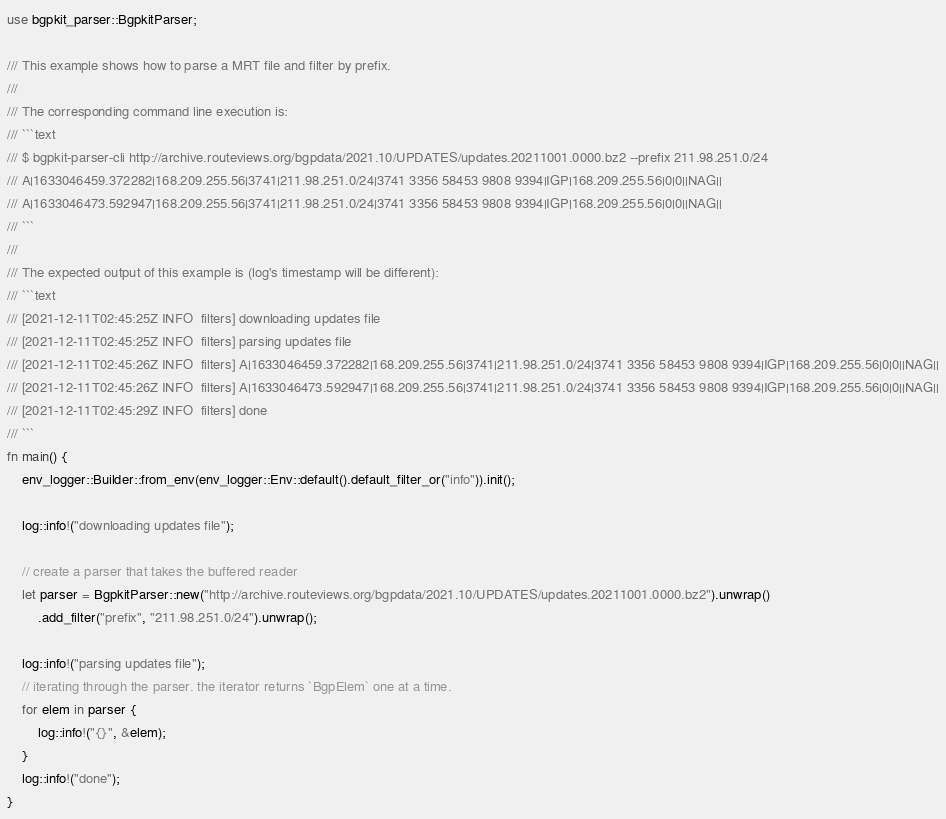Convert code to text. <code><loc_0><loc_0><loc_500><loc_500><_Rust_>use bgpkit_parser::BgpkitParser;

/// This example shows how to parse a MRT file and filter by prefix.
///
/// The corresponding command line execution is:
/// ```text
/// $ bgpkit-parser-cli http://archive.routeviews.org/bgpdata/2021.10/UPDATES/updates.20211001.0000.bz2 --prefix 211.98.251.0/24
/// A|1633046459.372282|168.209.255.56|3741|211.98.251.0/24|3741 3356 58453 9808 9394|IGP|168.209.255.56|0|0||NAG||
/// A|1633046473.592947|168.209.255.56|3741|211.98.251.0/24|3741 3356 58453 9808 9394|IGP|168.209.255.56|0|0||NAG||
/// ```
///
/// The expected output of this example is (log's timestamp will be different):
/// ```text
/// [2021-12-11T02:45:25Z INFO  filters] downloading updates file
/// [2021-12-11T02:45:25Z INFO  filters] parsing updates file
/// [2021-12-11T02:45:26Z INFO  filters] A|1633046459.372282|168.209.255.56|3741|211.98.251.0/24|3741 3356 58453 9808 9394|IGP|168.209.255.56|0|0||NAG||
/// [2021-12-11T02:45:26Z INFO  filters] A|1633046473.592947|168.209.255.56|3741|211.98.251.0/24|3741 3356 58453 9808 9394|IGP|168.209.255.56|0|0||NAG||
/// [2021-12-11T02:45:29Z INFO  filters] done
/// ```
fn main() {
    env_logger::Builder::from_env(env_logger::Env::default().default_filter_or("info")).init();

    log::info!("downloading updates file");

    // create a parser that takes the buffered reader
    let parser = BgpkitParser::new("http://archive.routeviews.org/bgpdata/2021.10/UPDATES/updates.20211001.0000.bz2").unwrap()
        .add_filter("prefix", "211.98.251.0/24").unwrap();

    log::info!("parsing updates file");
    // iterating through the parser. the iterator returns `BgpElem` one at a time.
    for elem in parser {
        log::info!("{}", &elem);
    }
    log::info!("done");
}
</code> 